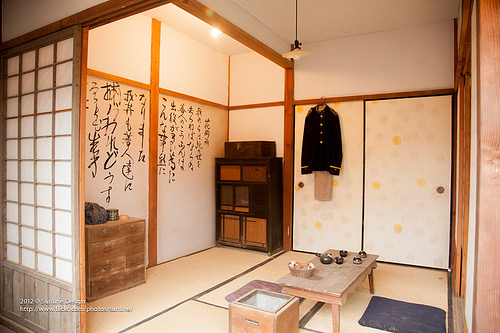<image>
Is the jacket in front of the door? Yes. The jacket is positioned in front of the door, appearing closer to the camera viewpoint. 